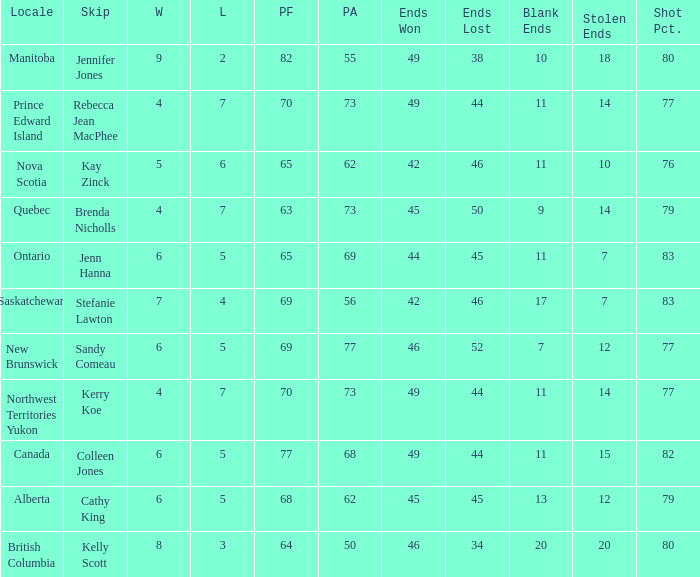What is the minimum PA when ends lost is 45? 62.0. 